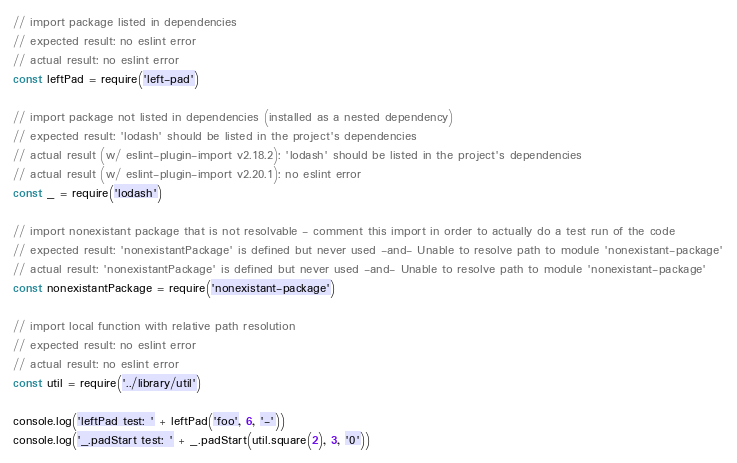<code> <loc_0><loc_0><loc_500><loc_500><_JavaScript_>// import package listed in dependencies
// expected result: no eslint error
// actual result: no eslint error
const leftPad = require('left-pad')

// import package not listed in dependencies (installed as a nested dependency)
// expected result: 'lodash' should be listed in the project's dependencies
// actual result (w/ eslint-plugin-import v2.18.2): 'lodash' should be listed in the project's dependencies
// actual result (w/ eslint-plugin-import v2.20.1): no eslint error
const _ = require('lodash')

// import nonexistant package that is not resolvable - comment this import in order to actually do a test run of the code
// expected result: 'nonexistantPackage' is defined but never used -and- Unable to resolve path to module 'nonexistant-package'
// actual result: 'nonexistantPackage' is defined but never used -and- Unable to resolve path to module 'nonexistant-package'
const nonexistantPackage = require('nonexistant-package')

// import local function with relative path resolution
// expected result: no eslint error
// actual result: no eslint error
const util = require('../library/util')

console.log('leftPad test: ' + leftPad('foo', 6, '-'))
console.log('_.padStart test: ' + _.padStart(util.square(2), 3, '0'))</code> 